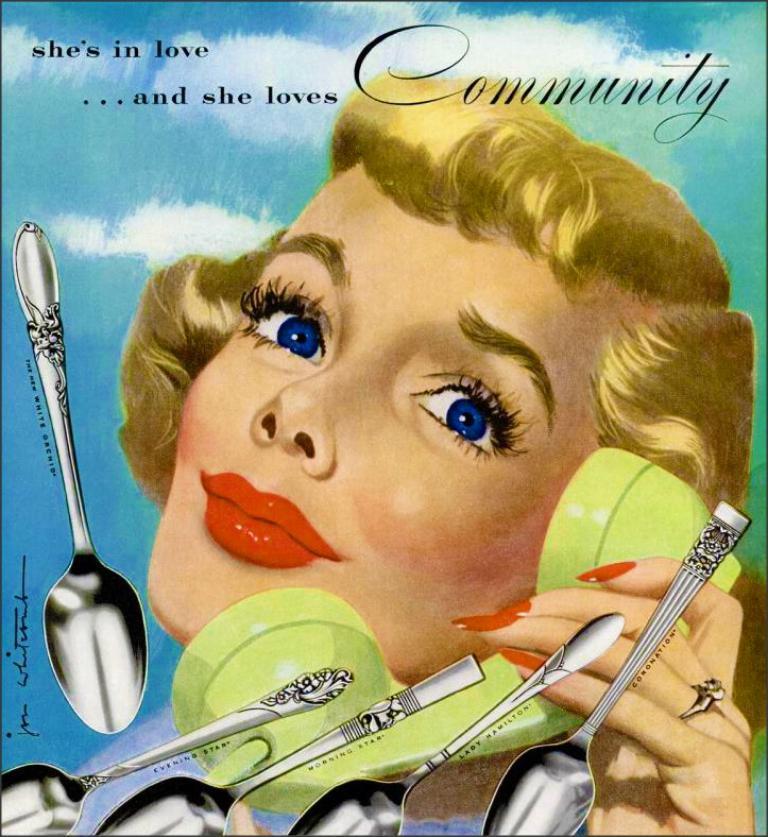Could you give a brief overview of what you see in this image? It is a painted image. In this image there is a woman holding the phone. There are spoons. In the background of the image there is sky. There is some text on the image. 